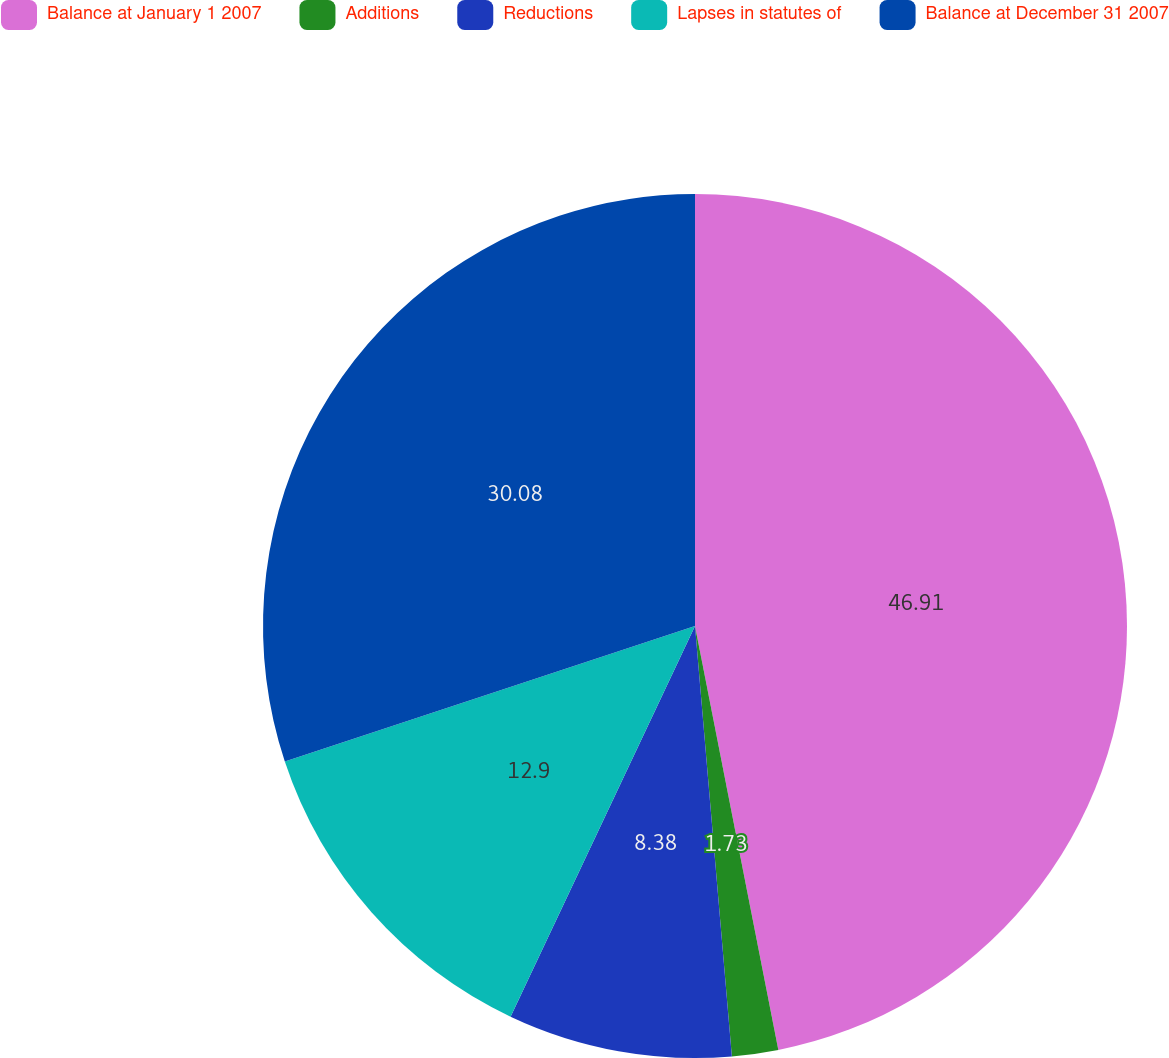<chart> <loc_0><loc_0><loc_500><loc_500><pie_chart><fcel>Balance at January 1 2007<fcel>Additions<fcel>Reductions<fcel>Lapses in statutes of<fcel>Balance at December 31 2007<nl><fcel>46.91%<fcel>1.73%<fcel>8.38%<fcel>12.9%<fcel>30.08%<nl></chart> 